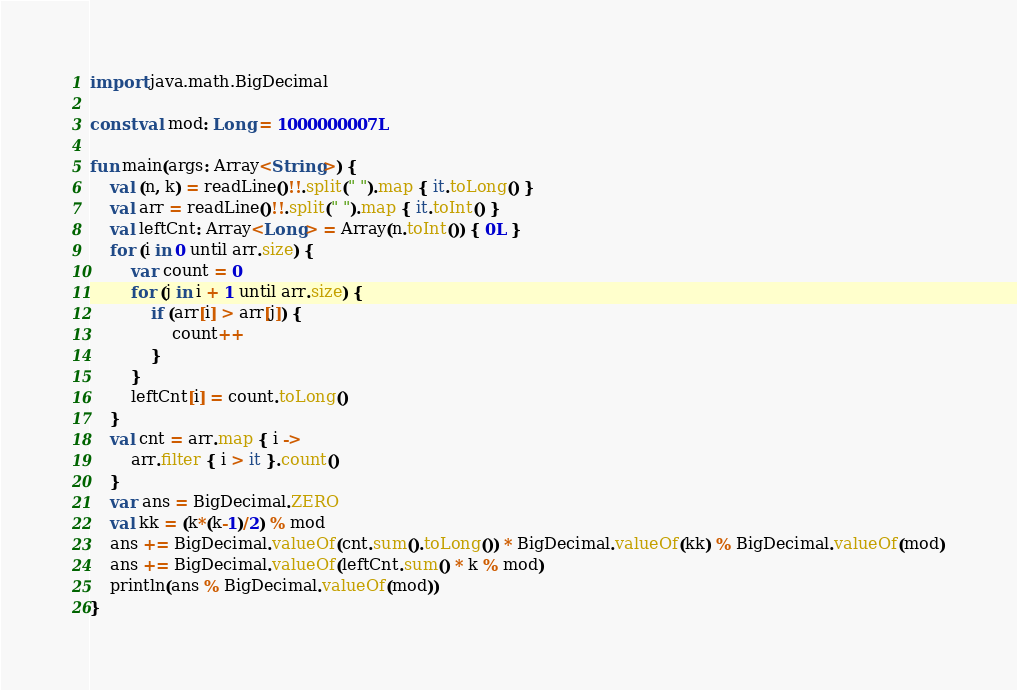<code> <loc_0><loc_0><loc_500><loc_500><_Kotlin_>import java.math.BigDecimal

const val mod: Long = 1000000007L

fun main(args: Array<String>) {
    val (n, k) = readLine()!!.split(" ").map { it.toLong() }
    val arr = readLine()!!.split(" ").map { it.toInt() }
    val leftCnt: Array<Long> = Array(n.toInt()) { 0L }
    for (i in 0 until arr.size) {
        var count = 0
        for (j in i + 1 until arr.size) {
            if (arr[i] > arr[j]) {
                count++
            }
        }
        leftCnt[i] = count.toLong()
    }
    val cnt = arr.map { i ->
        arr.filter { i > it }.count()
    }
    var ans = BigDecimal.ZERO
    val kk = (k*(k-1)/2) % mod
    ans += BigDecimal.valueOf(cnt.sum().toLong()) * BigDecimal.valueOf(kk) % BigDecimal.valueOf(mod)
    ans += BigDecimal.valueOf(leftCnt.sum() * k % mod)
    println(ans % BigDecimal.valueOf(mod))
}</code> 